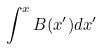Convert formula to latex. <formula><loc_0><loc_0><loc_500><loc_500>\int ^ { x } B ( x ^ { \prime } ) d x ^ { \prime }</formula> 